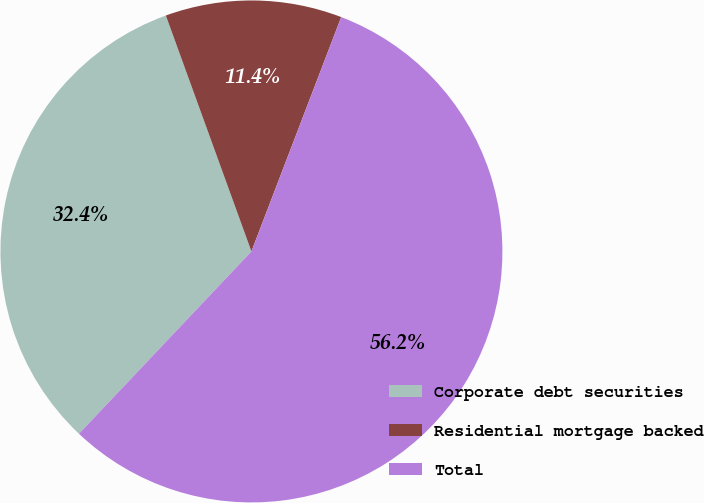<chart> <loc_0><loc_0><loc_500><loc_500><pie_chart><fcel>Corporate debt securities<fcel>Residential mortgage backed<fcel>Total<nl><fcel>32.4%<fcel>11.36%<fcel>56.23%<nl></chart> 